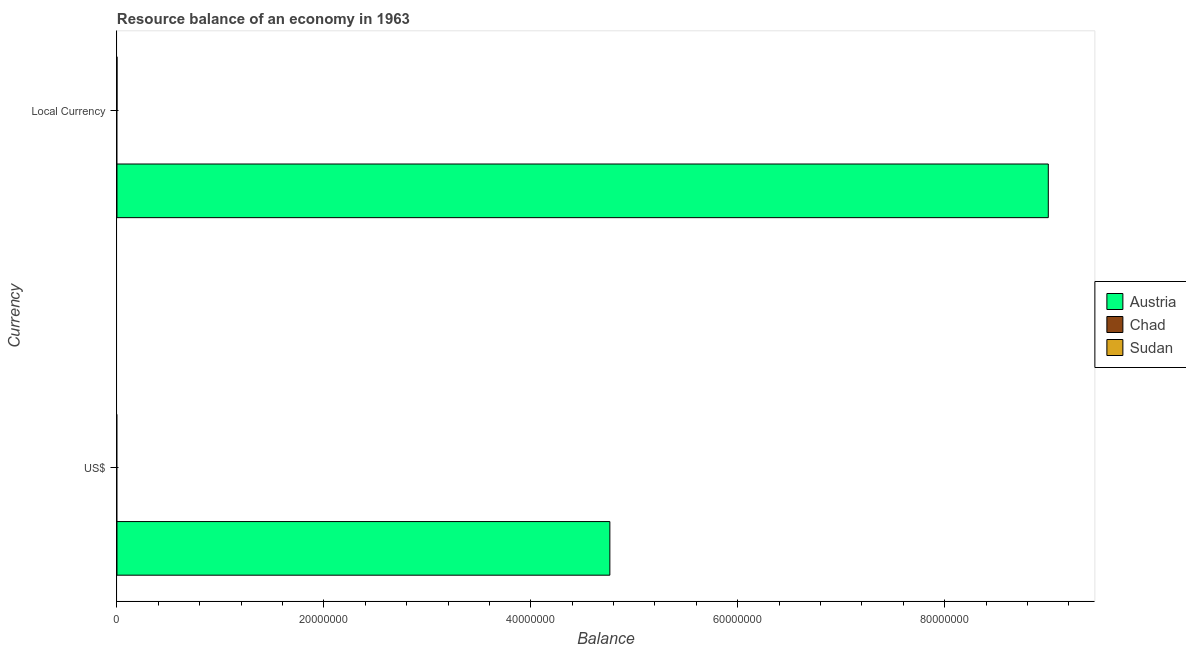How many different coloured bars are there?
Ensure brevity in your answer.  1. Are the number of bars per tick equal to the number of legend labels?
Provide a succinct answer. No. Are the number of bars on each tick of the Y-axis equal?
Keep it short and to the point. Yes. What is the label of the 2nd group of bars from the top?
Keep it short and to the point. US$. What is the resource balance in us$ in Austria?
Your response must be concise. 4.76e+07. Across all countries, what is the maximum resource balance in us$?
Your answer should be very brief. 4.76e+07. Across all countries, what is the minimum resource balance in us$?
Provide a short and direct response. 0. In which country was the resource balance in us$ maximum?
Give a very brief answer. Austria. What is the total resource balance in constant us$ in the graph?
Provide a succinct answer. 9.00e+07. What is the difference between the resource balance in us$ in Austria and the resource balance in constant us$ in Sudan?
Provide a succinct answer. 4.76e+07. What is the average resource balance in constant us$ per country?
Your answer should be compact. 3.00e+07. What is the difference between the resource balance in us$ and resource balance in constant us$ in Austria?
Provide a succinct answer. -4.24e+07. In how many countries, is the resource balance in constant us$ greater than 16000000 units?
Give a very brief answer. 1. In how many countries, is the resource balance in us$ greater than the average resource balance in us$ taken over all countries?
Give a very brief answer. 1. How many bars are there?
Keep it short and to the point. 2. How many countries are there in the graph?
Provide a succinct answer. 3. What is the difference between two consecutive major ticks on the X-axis?
Your response must be concise. 2.00e+07. Are the values on the major ticks of X-axis written in scientific E-notation?
Keep it short and to the point. No. Does the graph contain grids?
Make the answer very short. No. Where does the legend appear in the graph?
Your answer should be compact. Center right. How are the legend labels stacked?
Offer a terse response. Vertical. What is the title of the graph?
Your response must be concise. Resource balance of an economy in 1963. Does "Macao" appear as one of the legend labels in the graph?
Ensure brevity in your answer.  No. What is the label or title of the X-axis?
Your answer should be compact. Balance. What is the label or title of the Y-axis?
Make the answer very short. Currency. What is the Balance of Austria in US$?
Your answer should be very brief. 4.76e+07. What is the Balance in Sudan in US$?
Make the answer very short. 0. What is the Balance of Austria in Local Currency?
Your response must be concise. 9.00e+07. What is the Balance of Sudan in Local Currency?
Your answer should be very brief. 0. Across all Currency, what is the maximum Balance in Austria?
Give a very brief answer. 9.00e+07. Across all Currency, what is the minimum Balance of Austria?
Make the answer very short. 4.76e+07. What is the total Balance in Austria in the graph?
Offer a terse response. 1.38e+08. What is the total Balance of Chad in the graph?
Your answer should be very brief. 0. What is the difference between the Balance of Austria in US$ and that in Local Currency?
Provide a short and direct response. -4.24e+07. What is the average Balance in Austria per Currency?
Offer a very short reply. 6.88e+07. What is the average Balance of Chad per Currency?
Provide a succinct answer. 0. What is the average Balance in Sudan per Currency?
Your response must be concise. 0. What is the ratio of the Balance in Austria in US$ to that in Local Currency?
Make the answer very short. 0.53. What is the difference between the highest and the second highest Balance in Austria?
Give a very brief answer. 4.24e+07. What is the difference between the highest and the lowest Balance of Austria?
Provide a succinct answer. 4.24e+07. 